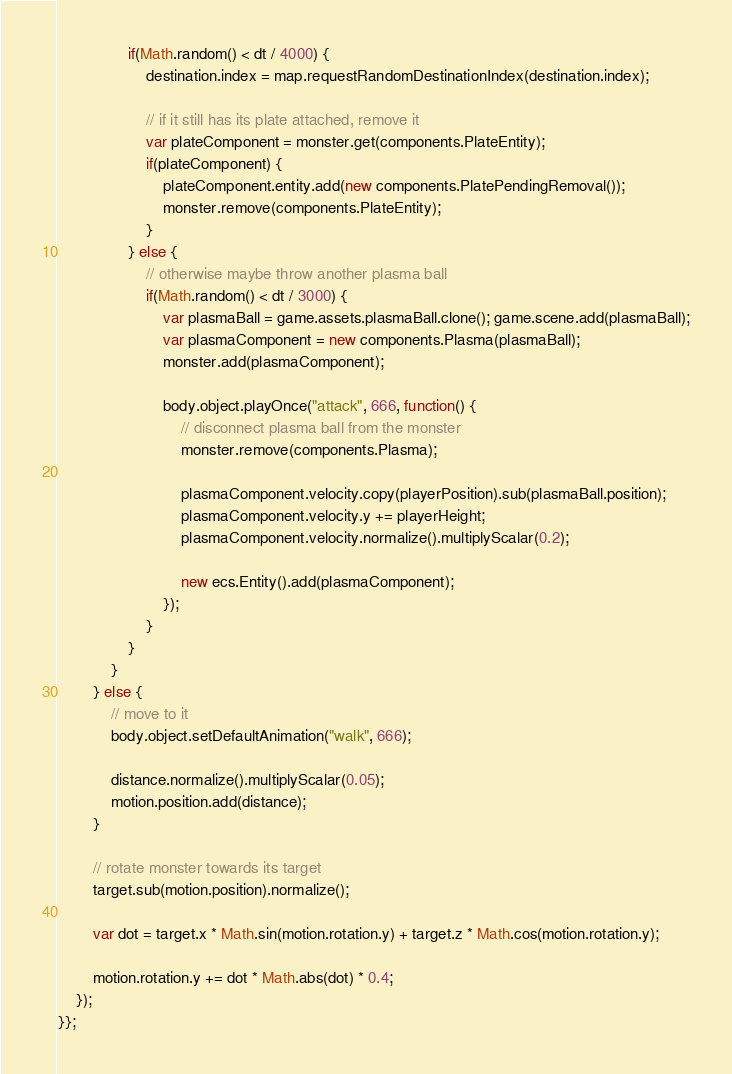<code> <loc_0><loc_0><loc_500><loc_500><_JavaScript_>				if(Math.random() < dt / 4000) {
					destination.index = map.requestRandomDestinationIndex(destination.index);

					// if it still has its plate attached, remove it
					var plateComponent = monster.get(components.PlateEntity);
					if(plateComponent) {
						plateComponent.entity.add(new components.PlatePendingRemoval());
						monster.remove(components.PlateEntity);
					}
				} else {
					// otherwise maybe throw another plasma ball
					if(Math.random() < dt / 3000) {
						var plasmaBall = game.assets.plasmaBall.clone(); game.scene.add(plasmaBall);
						var plasmaComponent = new components.Plasma(plasmaBall);
						monster.add(plasmaComponent);

						body.object.playOnce("attack", 666, function() {
							// disconnect plasma ball from the monster
							monster.remove(components.Plasma);

							plasmaComponent.velocity.copy(playerPosition).sub(plasmaBall.position);
							plasmaComponent.velocity.y += playerHeight;
							plasmaComponent.velocity.normalize().multiplyScalar(0.2);

							new ecs.Entity().add(plasmaComponent);
						});
					}
				}
			}
		} else {
			// move to it
			body.object.setDefaultAnimation("walk", 666);

			distance.normalize().multiplyScalar(0.05);
			motion.position.add(distance);
		}

		// rotate monster towards its target
		target.sub(motion.position).normalize();

		var dot = target.x * Math.sin(motion.rotation.y) + target.z * Math.cos(motion.rotation.y);

		motion.rotation.y += dot * Math.abs(dot) * 0.4;
	});
}};
</code> 